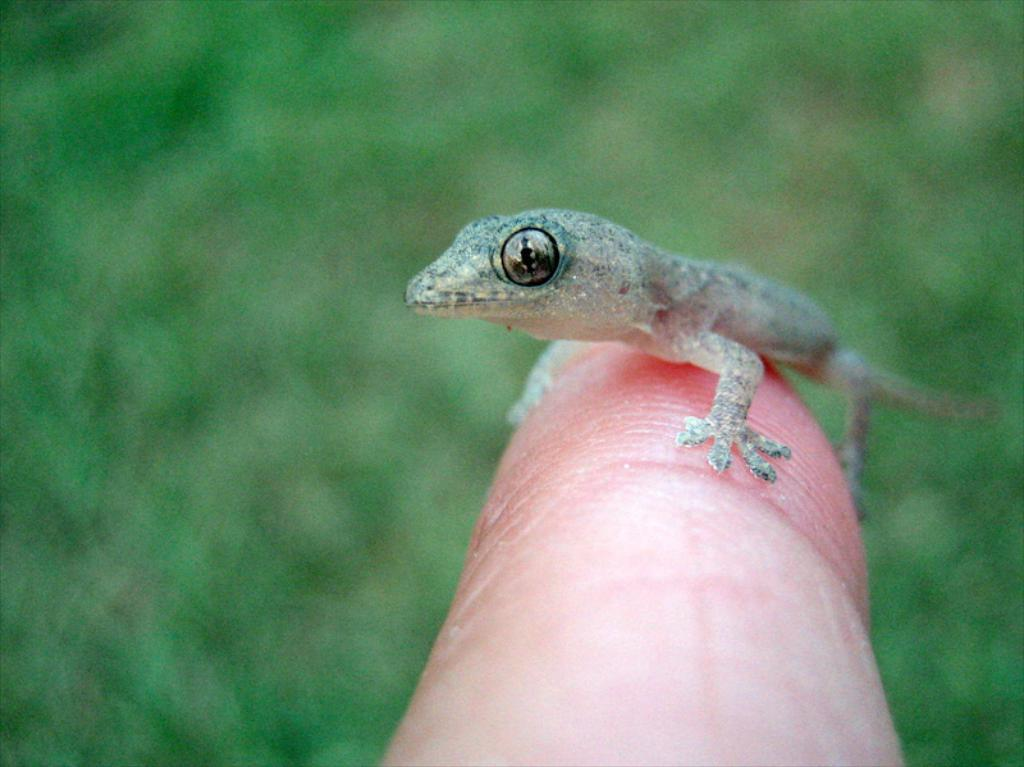What type of animal is in the image? There is a lizard in the image. What color is the lizard? The lizard is grey in color. Where is the lizard located in the image? The lizard is on a person's finger. What can be seen in the background of the image? The background of the image is green. What type of sail can be seen in the image? There is no sail present in the image; it features a lizard on a person's finger with a green background. What type of lace is used to decorate the lizard's habitat in the image? There is no lace present in the image, as it focuses on the lizard and its location on a person's finger. 